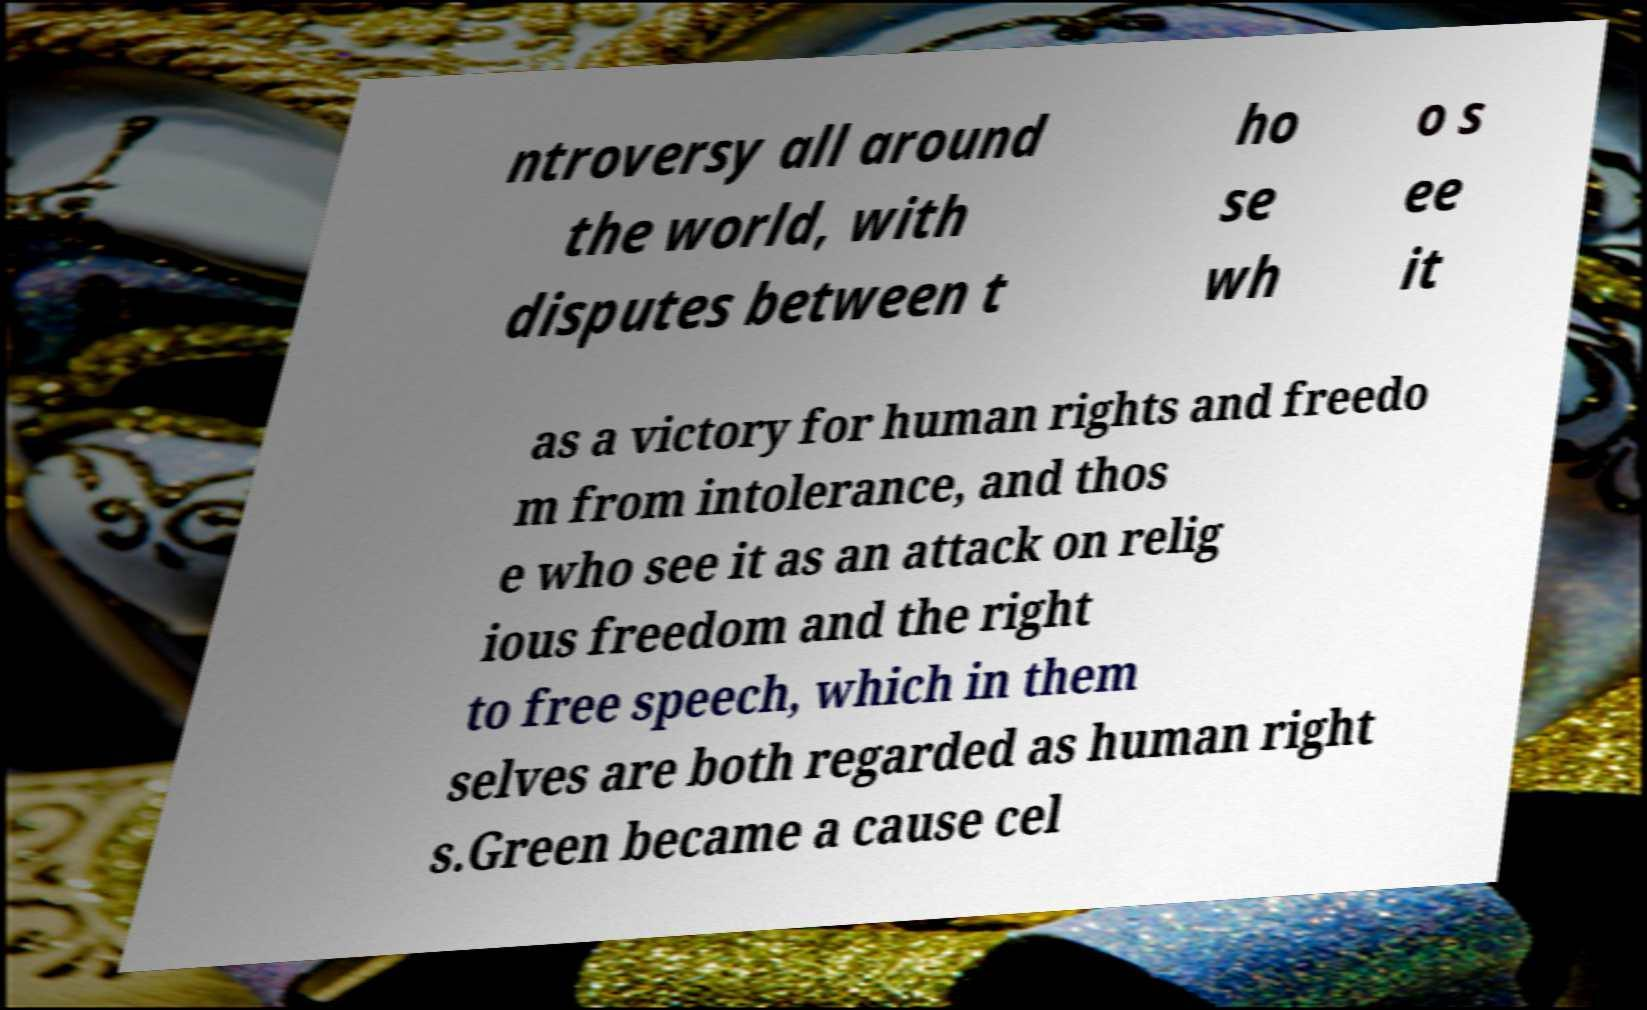Can you accurately transcribe the text from the provided image for me? ntroversy all around the world, with disputes between t ho se wh o s ee it as a victory for human rights and freedo m from intolerance, and thos e who see it as an attack on relig ious freedom and the right to free speech, which in them selves are both regarded as human right s.Green became a cause cel 